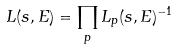<formula> <loc_0><loc_0><loc_500><loc_500>L ( s , E ) = \prod _ { p } L _ { p } ( s , E ) ^ { - 1 }</formula> 